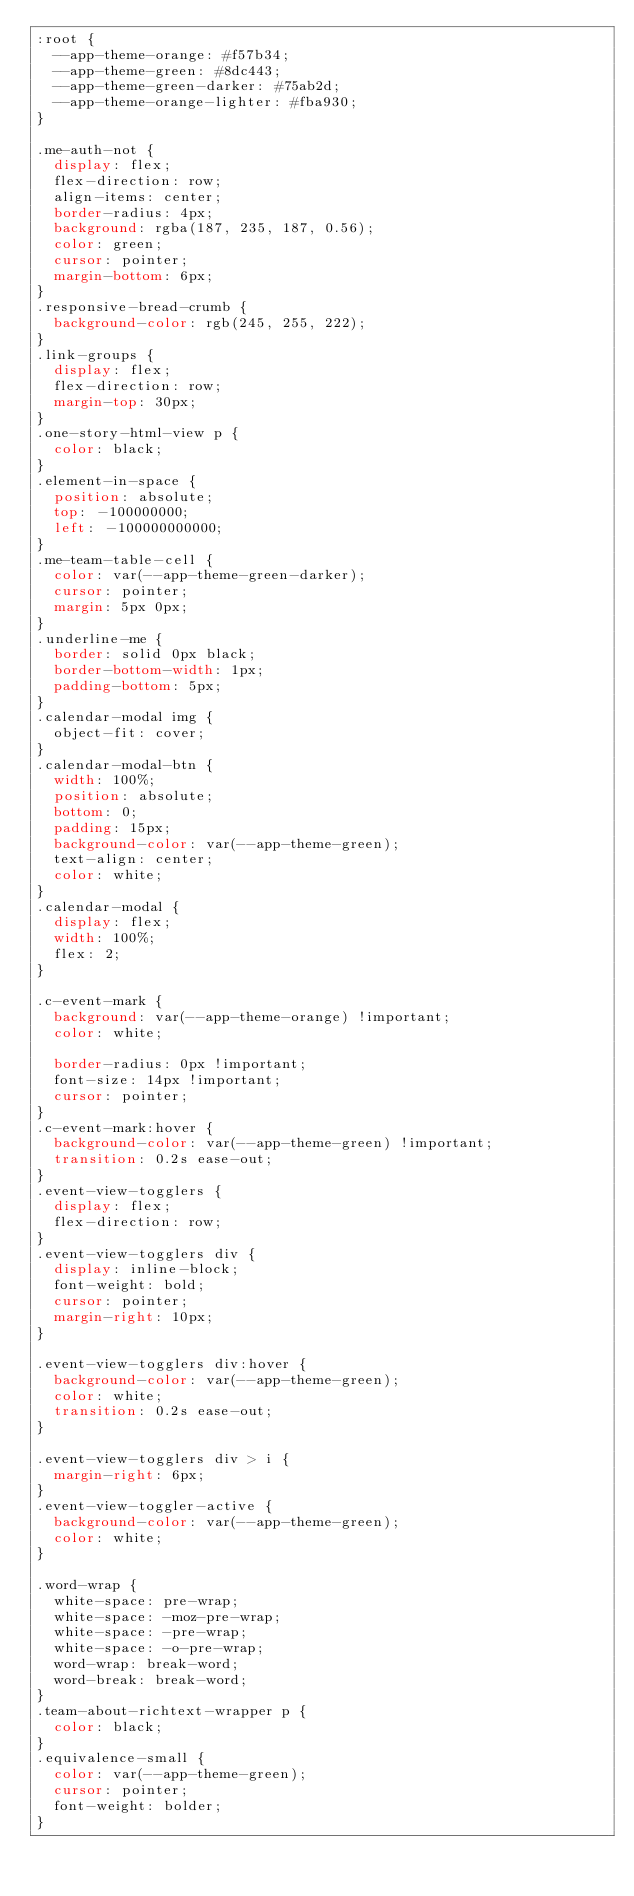Convert code to text. <code><loc_0><loc_0><loc_500><loc_500><_CSS_>:root {
  --app-theme-orange: #f57b34;
  --app-theme-green: #8dc443;
  --app-theme-green-darker: #75ab2d;
  --app-theme-orange-lighter: #fba930;
}

.me-auth-not {
  display: flex;
  flex-direction: row;
  align-items: center;
  border-radius: 4px;
  background: rgba(187, 235, 187, 0.56);
  color: green;
  cursor: pointer;
  margin-bottom: 6px;
}
.responsive-bread-crumb {
  background-color: rgb(245, 255, 222);
}
.link-groups {
  display: flex;
  flex-direction: row;
  margin-top: 30px;
}
.one-story-html-view p {
  color: black;
}
.element-in-space {
  position: absolute;
  top: -100000000;
  left: -100000000000;
}
.me-team-table-cell {
  color: var(--app-theme-green-darker);
  cursor: pointer;
  margin: 5px 0px;
}
.underline-me {
  border: solid 0px black;
  border-bottom-width: 1px;
  padding-bottom: 5px;
}
.calendar-modal img {
  object-fit: cover;
}
.calendar-modal-btn {
  width: 100%;
  position: absolute;
  bottom: 0;
  padding: 15px;
  background-color: var(--app-theme-green);
  text-align: center;
  color: white;
}
.calendar-modal {
  display: flex;
  width: 100%;
  flex: 2;
}

.c-event-mark {
  background: var(--app-theme-orange) !important;
  color: white;

  border-radius: 0px !important;
  font-size: 14px !important;
  cursor: pointer;
}
.c-event-mark:hover {
  background-color: var(--app-theme-green) !important;
  transition: 0.2s ease-out;
}
.event-view-togglers {
  display: flex;
  flex-direction: row;
}
.event-view-togglers div {
  display: inline-block;
  font-weight: bold;
  cursor: pointer;
  margin-right: 10px;
}

.event-view-togglers div:hover {
  background-color: var(--app-theme-green);
  color: white;
  transition: 0.2s ease-out;
}

.event-view-togglers div > i {
  margin-right: 6px;
}
.event-view-toggler-active {
  background-color: var(--app-theme-green);
  color: white;
}

.word-wrap {
  white-space: pre-wrap;
  white-space: -moz-pre-wrap;
  white-space: -pre-wrap;
  white-space: -o-pre-wrap;
  word-wrap: break-word;
  word-break: break-word;
}
.team-about-richtext-wrapper p {
  color: black;
}
.equivalence-small {
  color: var(--app-theme-green);
  cursor: pointer;
  font-weight: bolder;
}
</code> 